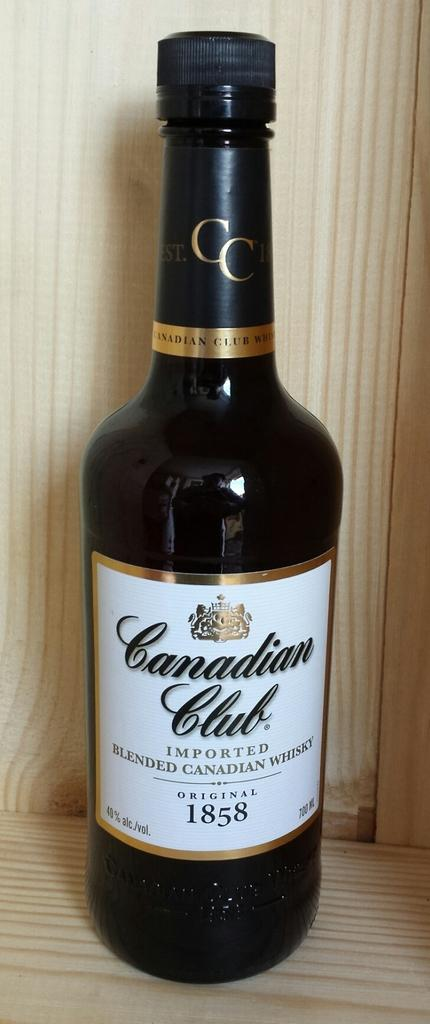<image>
Share a concise interpretation of the image provided. A dark bottle of whiskey by Canadian Club. 